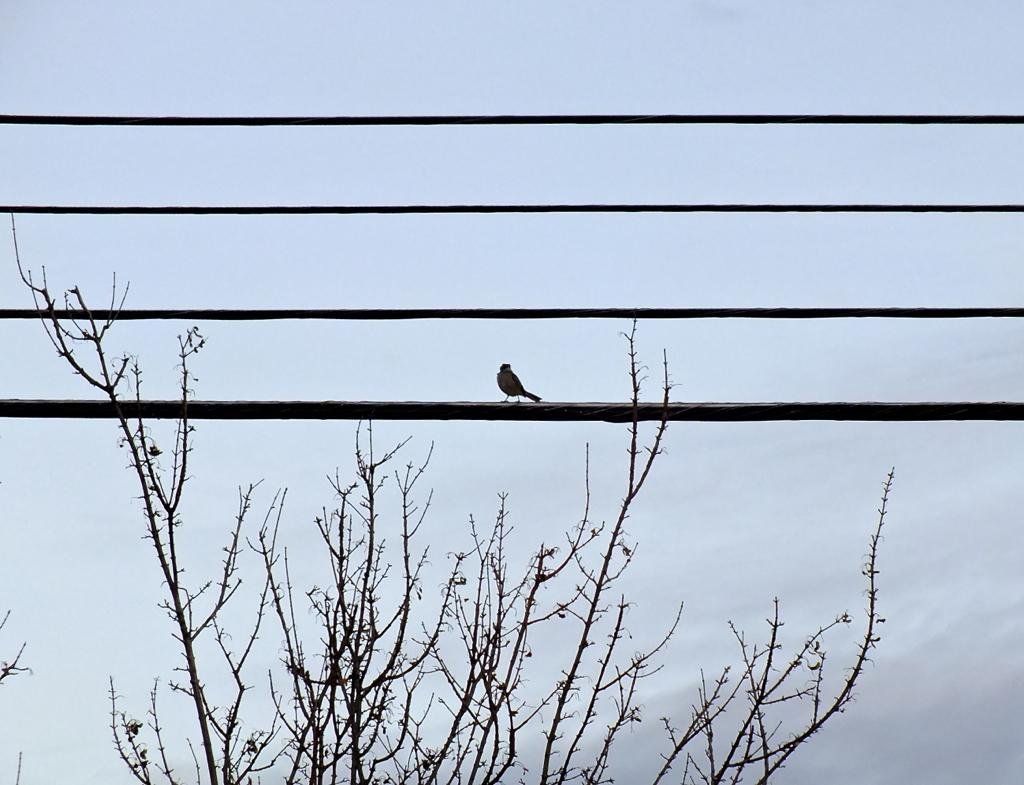What can be seen running through the image? There are wires in the image. Is there any wildlife visible on the wires? Yes, a bird is present on one of the wires. What type of vegetation is at the bottom of the image? There are trees at the bottom of the image. What is visible in the background of the image? The sky is visible in the background of the image. How many bottles are visible in the image? There are no bottles present in the image. What type of art can be seen on the wires? There is no art present on the wires; only a bird is visible. 